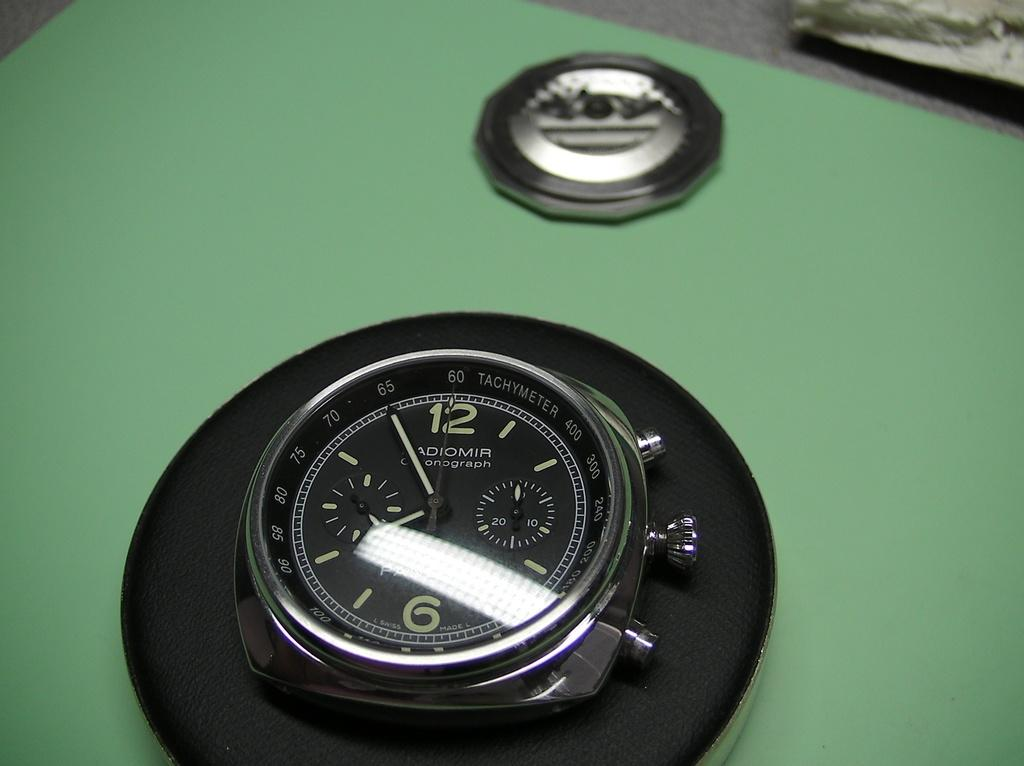Provide a one-sentence caption for the provided image. A pocket watch is sitting on display showing 7:55. 